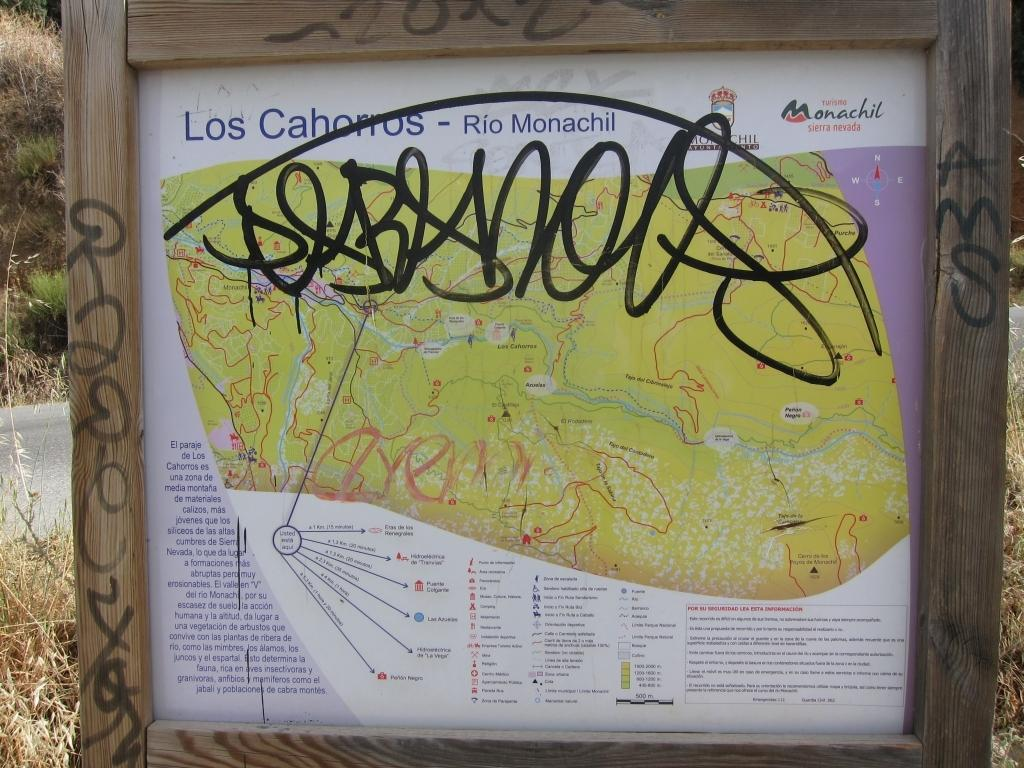<image>
Present a compact description of the photo's key features. A vandalized, graffiti covered map pertains to the Sierra Nevada area. 